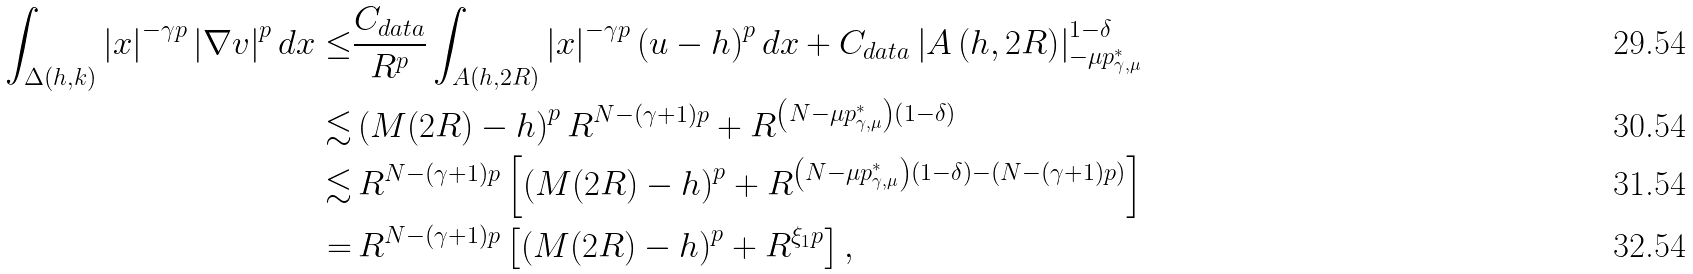<formula> <loc_0><loc_0><loc_500><loc_500>\int _ { \Delta ( h , k ) } \left | x \right | ^ { - \gamma p } \left | \nabla v \right | ^ { p } d x \leq & \frac { C _ { d a t a } } { R ^ { p } } \int _ { A ( h , 2 R ) } \left | x \right | ^ { - \gamma p } \left ( u - h \right ) ^ { p } d x + C _ { d a t a } \left | A \left ( h , 2 R \right ) \right | _ { - \mu p _ { \gamma , \mu } ^ { * } } ^ { 1 - \delta } \\ \lesssim & \left ( M ( 2 R ) - h \right ) ^ { p } R ^ { N - \left ( \gamma + 1 \right ) p } + R ^ { \left ( N - \mu p _ { \gamma , \mu } ^ { * } \right ) \left ( 1 - \delta \right ) } \\ \lesssim & \, R ^ { N - \left ( \gamma + 1 \right ) p } \left [ \left ( M ( 2 R ) - h \right ) ^ { p } + R ^ { \left ( N - \mu p _ { \gamma , \mu } ^ { * } \right ) \left ( 1 - \delta \right ) - \left ( N - \left ( \gamma + 1 \right ) p \right ) } \right ] \\ = & \, R ^ { N - \left ( \gamma + 1 \right ) p } \left [ \left ( M ( 2 R ) - h \right ) ^ { p } + R ^ { \xi _ { 1 } p } \right ] ,</formula> 